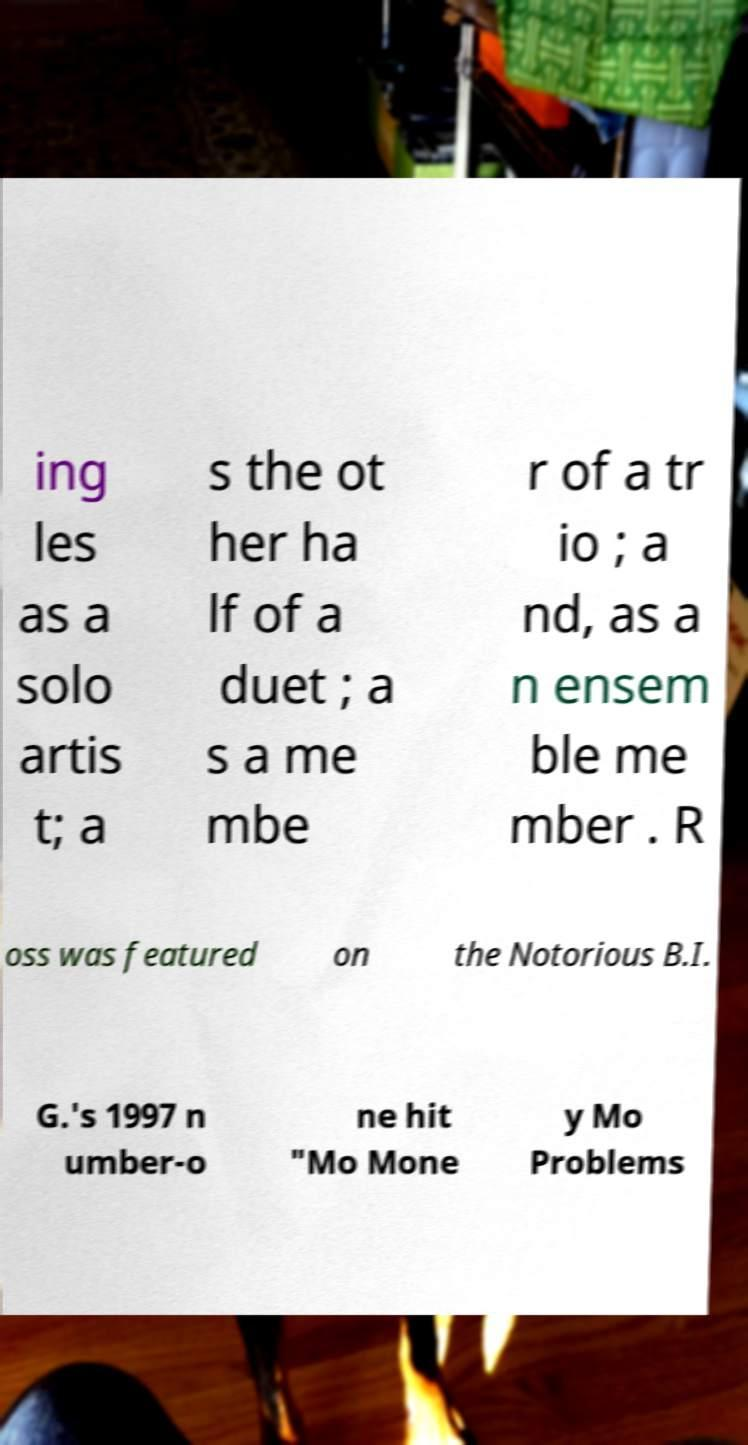Please identify and transcribe the text found in this image. ing les as a solo artis t; a s the ot her ha lf of a duet ; a s a me mbe r of a tr io ; a nd, as a n ensem ble me mber . R oss was featured on the Notorious B.I. G.'s 1997 n umber-o ne hit "Mo Mone y Mo Problems 